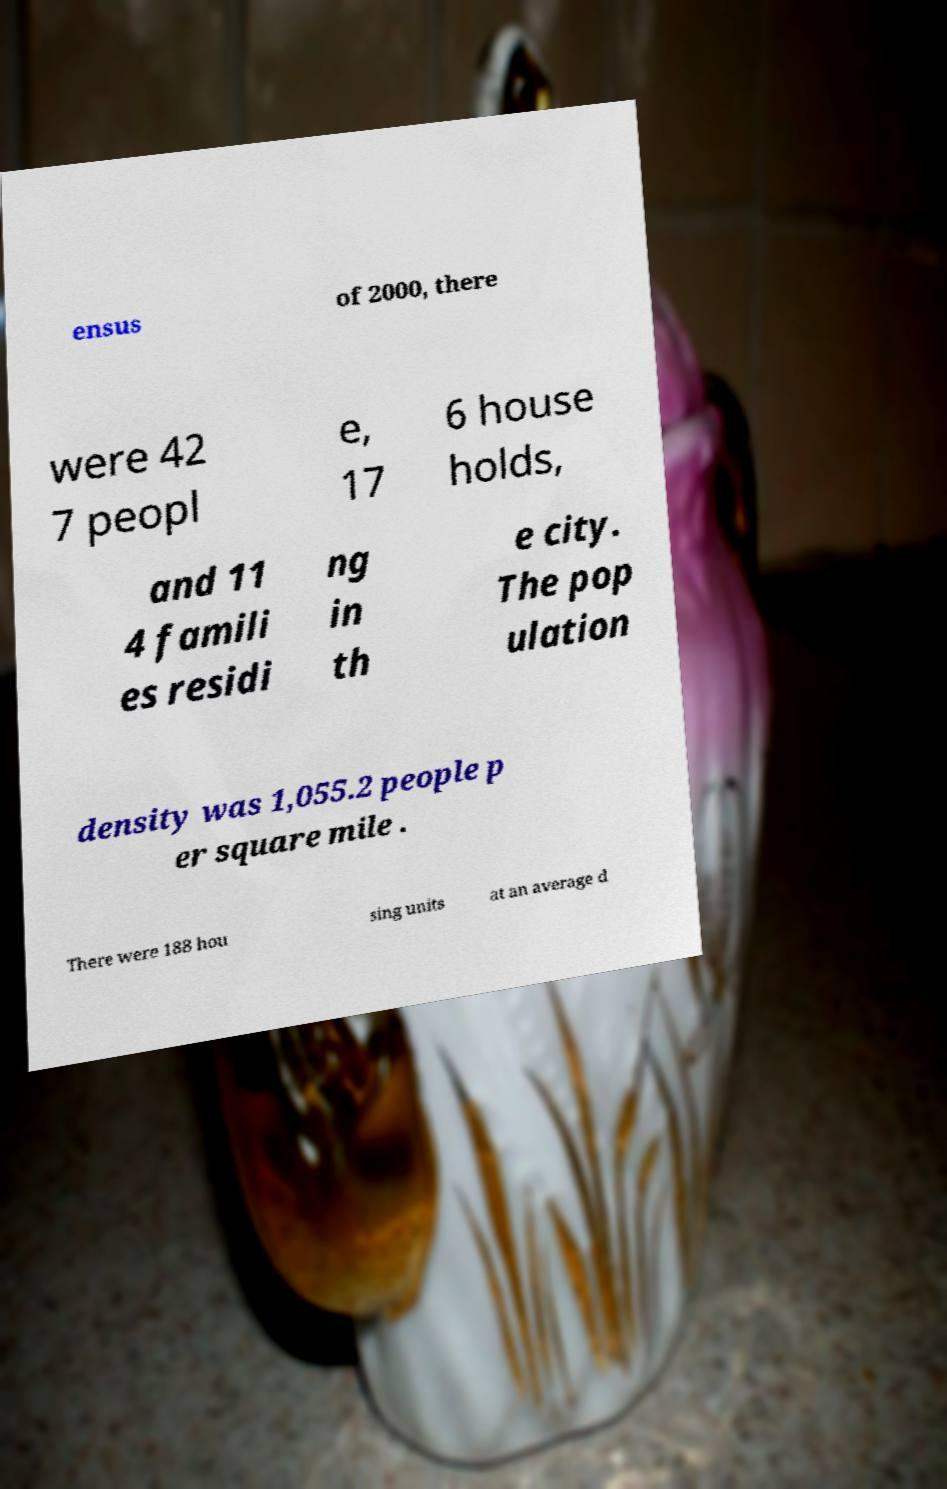I need the written content from this picture converted into text. Can you do that? ensus of 2000, there were 42 7 peopl e, 17 6 house holds, and 11 4 famili es residi ng in th e city. The pop ulation density was 1,055.2 people p er square mile . There were 188 hou sing units at an average d 